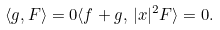<formula> <loc_0><loc_0><loc_500><loc_500>\langle g , F \rangle = 0 \langle f + g , \, | x | ^ { 2 } F \rangle = 0 .</formula> 